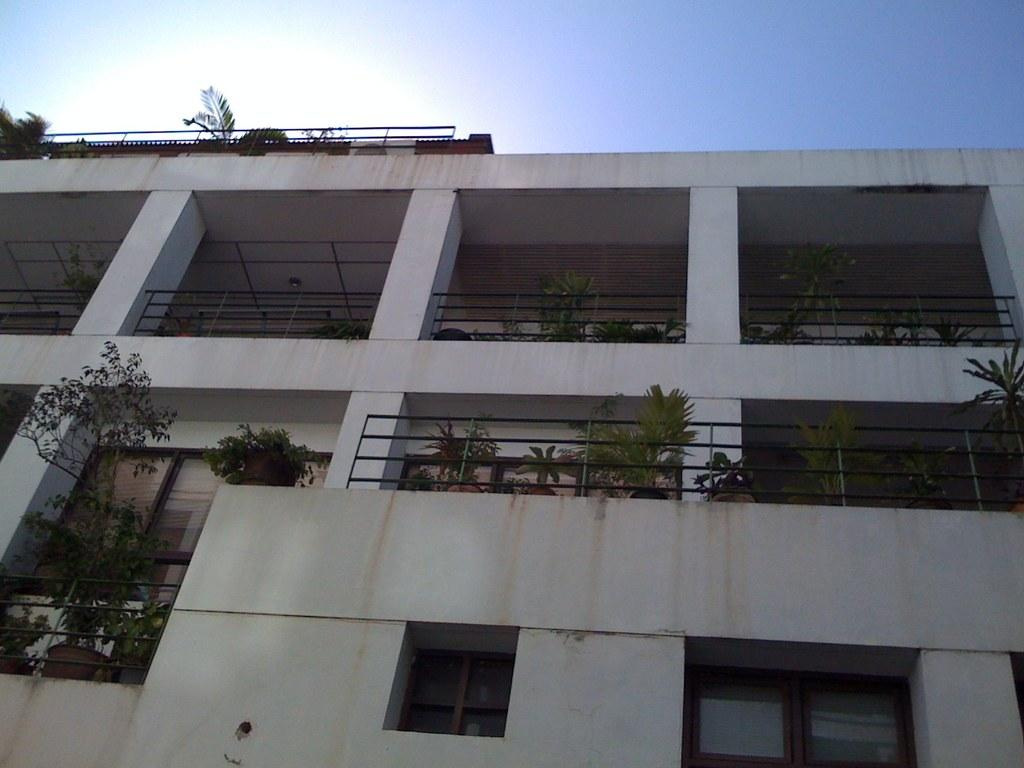What is the main subject in the center of the image? There is a building in the center of the image. What is the color of the building? The building is white in color. Are there any plants visible in the image? Yes, there are plants on the balcony and the top of the building. Can you see a train passing by the building in the image? There is no train visible in the image; it only features a white building with plants on the balcony and top. 